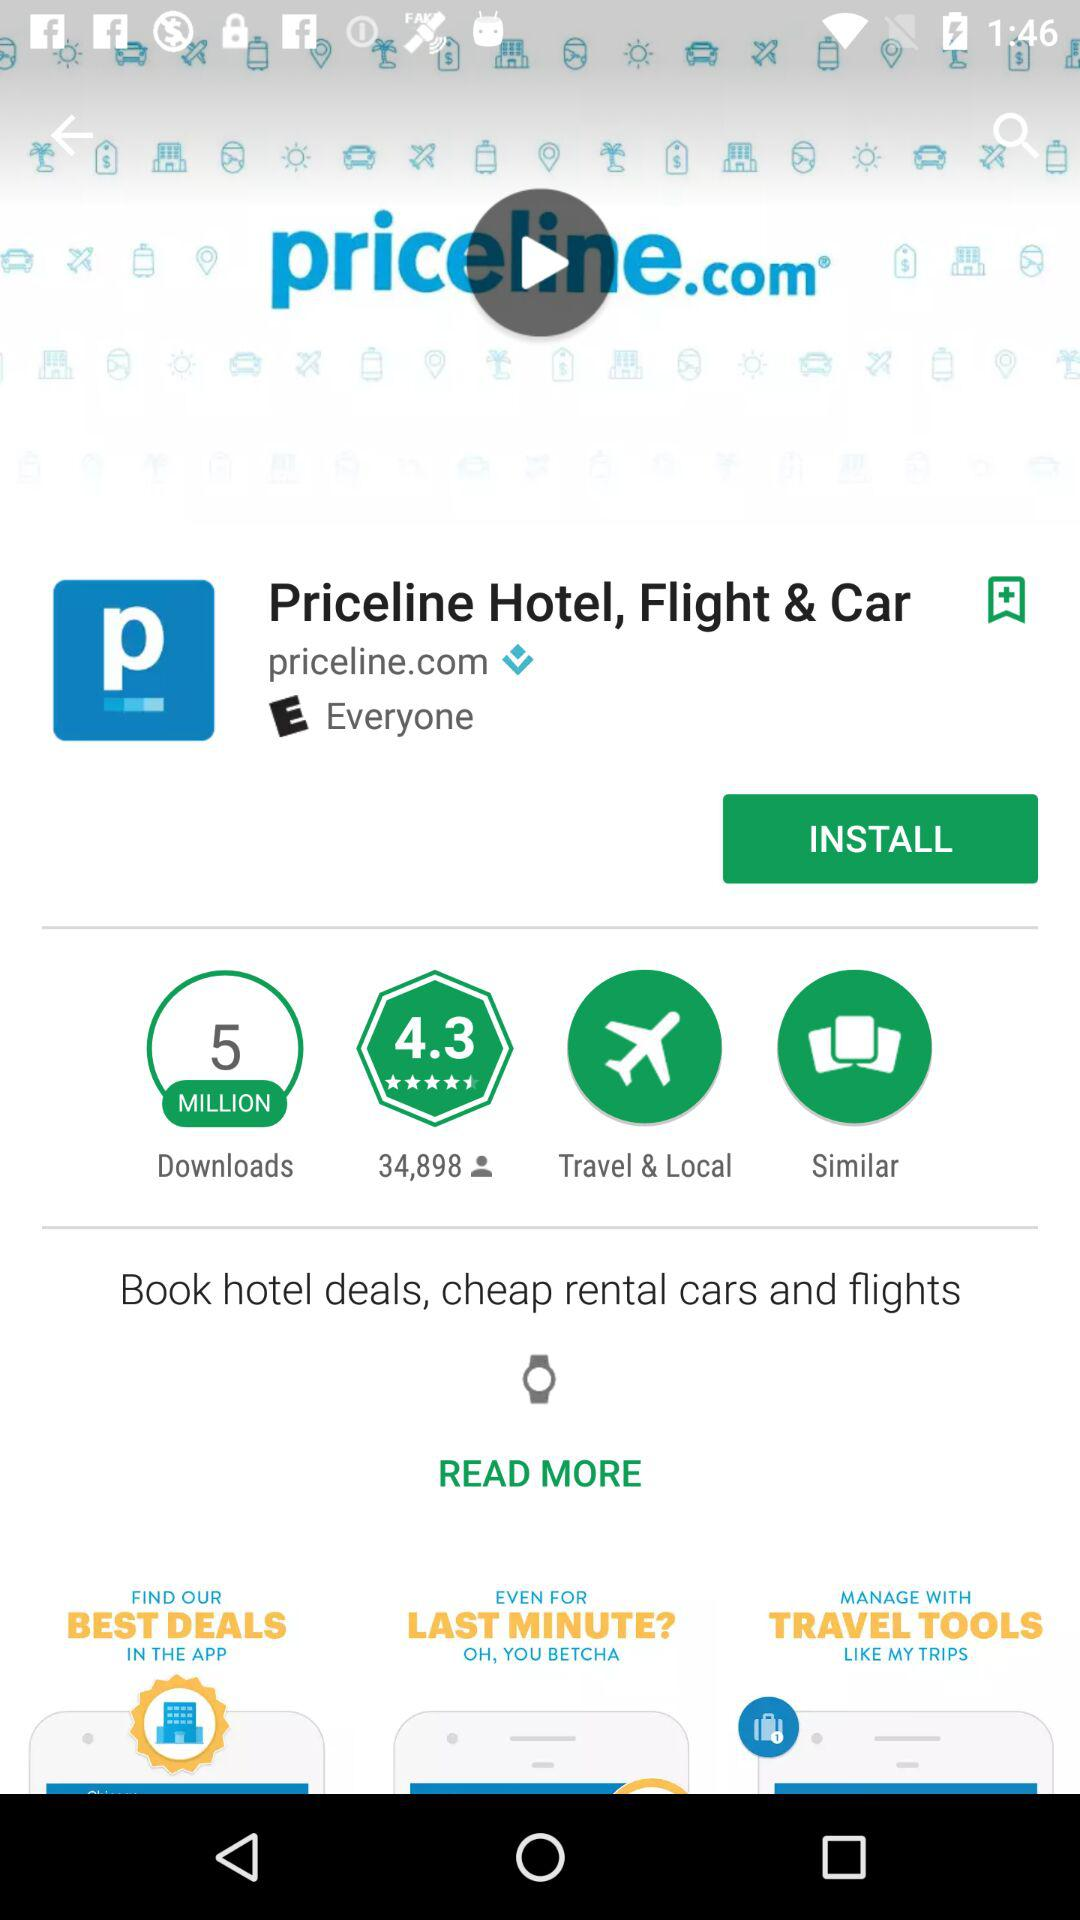What is the application name? The application name is "Priceline Hotel, Flight & Car". 